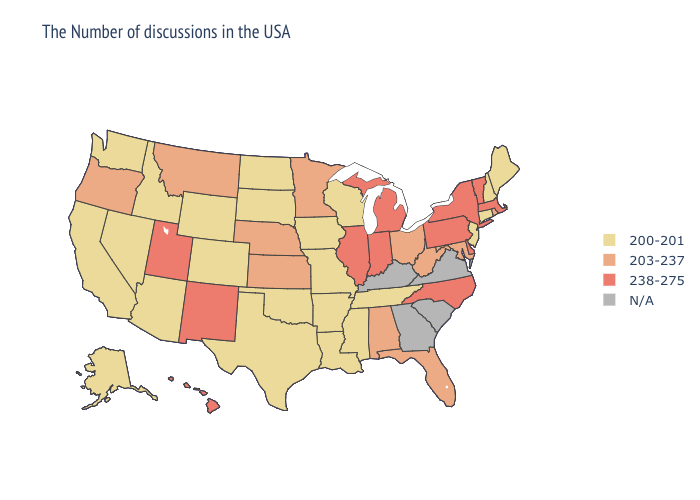What is the lowest value in the South?
Concise answer only. 200-201. Name the states that have a value in the range N/A?
Give a very brief answer. Virginia, South Carolina, Georgia, Kentucky. Among the states that border Missouri , does Kansas have the lowest value?
Give a very brief answer. No. Is the legend a continuous bar?
Concise answer only. No. Does North Carolina have the lowest value in the USA?
Keep it brief. No. Does the map have missing data?
Short answer required. Yes. Does New Hampshire have the lowest value in the Northeast?
Answer briefly. Yes. Name the states that have a value in the range 200-201?
Concise answer only. Maine, New Hampshire, Connecticut, New Jersey, Tennessee, Wisconsin, Mississippi, Louisiana, Missouri, Arkansas, Iowa, Oklahoma, Texas, South Dakota, North Dakota, Wyoming, Colorado, Arizona, Idaho, Nevada, California, Washington, Alaska. What is the value of California?
Concise answer only. 200-201. Name the states that have a value in the range 200-201?
Concise answer only. Maine, New Hampshire, Connecticut, New Jersey, Tennessee, Wisconsin, Mississippi, Louisiana, Missouri, Arkansas, Iowa, Oklahoma, Texas, South Dakota, North Dakota, Wyoming, Colorado, Arizona, Idaho, Nevada, California, Washington, Alaska. Is the legend a continuous bar?
Give a very brief answer. No. Does Delaware have the highest value in the USA?
Concise answer only. Yes. How many symbols are there in the legend?
Keep it brief. 4. Which states have the lowest value in the MidWest?
Give a very brief answer. Wisconsin, Missouri, Iowa, South Dakota, North Dakota. 